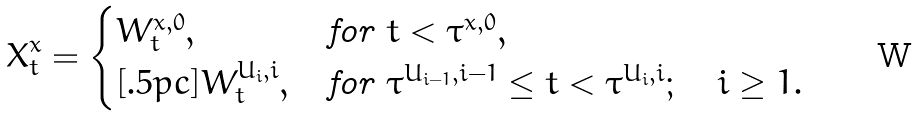Convert formula to latex. <formula><loc_0><loc_0><loc_500><loc_500>X ^ { x } _ { t } = \begin{cases} W ^ { x , 0 } _ { t } , & \text {for $t < \tau^{x,0}$} , \\ [ . 5 p c ] W ^ { U _ { i } , i } _ { t } , & \text {for $\tau^{U_{i-1},i-1} \leq t < \tau^{U_{i},i}; \quad i\geq 1$} . \end{cases}</formula> 